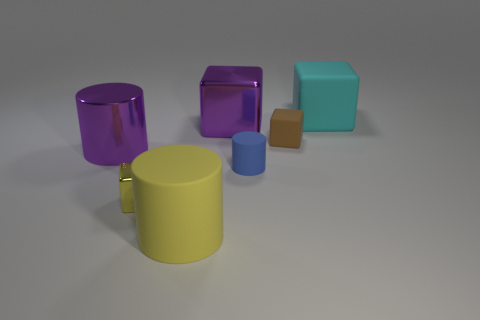Does the purple cube have the same size as the blue cylinder?
Ensure brevity in your answer.  No. Is there anything else that is the same shape as the tiny shiny thing?
Provide a succinct answer. Yes. What number of things are either small things in front of the blue object or yellow cylinders?
Your answer should be very brief. 2. Is the shape of the large cyan object the same as the blue matte thing?
Give a very brief answer. No. What number of other things are there of the same size as the cyan block?
Your response must be concise. 3. The large metal cylinder is what color?
Offer a very short reply. Purple. What number of tiny objects are either yellow rubber things or cyan metal cubes?
Your answer should be very brief. 0. Is the size of the cylinder that is to the left of the small metal block the same as the thing in front of the tiny metallic cube?
Ensure brevity in your answer.  Yes. There is a blue object that is the same shape as the big yellow object; what is its size?
Offer a terse response. Small. Are there more brown rubber cubes to the right of the blue thing than large things that are to the right of the cyan matte block?
Your answer should be compact. Yes. 